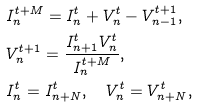<formula> <loc_0><loc_0><loc_500><loc_500>& I _ { n } ^ { t + M } = I _ { n } ^ { t } + V _ { n } ^ { t } - V _ { n - 1 } ^ { t + 1 } , \\ & V _ { n } ^ { t + 1 } = \frac { I _ { n + 1 } ^ { t } V _ { n } ^ { t } } { I _ { n } ^ { t + M } } , \\ & I _ { n } ^ { t } = I _ { n + N } ^ { t } , \quad V _ { n } ^ { t } = V _ { n + N } ^ { t } ,</formula> 